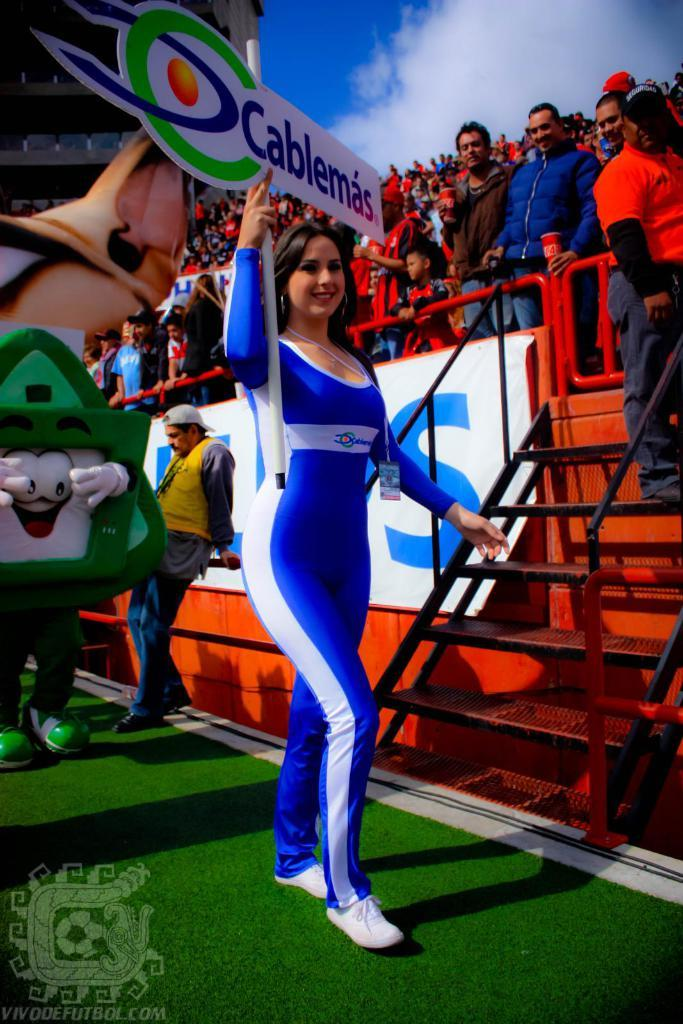<image>
Create a compact narrative representing the image presented. The girl carrying the Cablemas sign is wearing a blue jumpsuit 